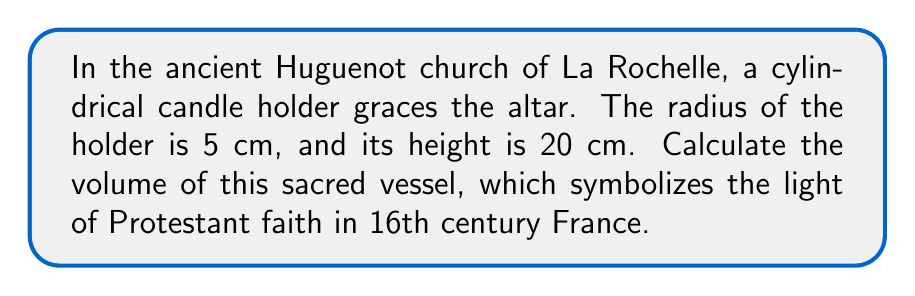Show me your answer to this math problem. To calculate the volume of a cylindrical candle holder, we use the formula for the volume of a cylinder:

$$V = \pi r^2 h$$

Where:
$V$ = volume
$r$ = radius of the base
$h$ = height of the cylinder

Given:
$r = 5$ cm
$h = 20$ cm

Let's substitute these values into the formula:

$$V = \pi (5\text{ cm})^2 (20\text{ cm})$$

Simplify:
$$V = \pi (25\text{ cm}^2) (20\text{ cm})$$
$$V = 500\pi\text{ cm}^3$$

We can leave the answer in terms of $\pi$ or calculate an approximate value:

$$V \approx 500 \times 3.14159 \approx 1570.80\text{ cm}^3$$

[asy]
import geometry;

size(100);
path p = circle((0,0),1);
path q = circle((0,2),1);
draw(p);
draw(q);
draw((-1,0)--(1,0));
draw((-1,2)--(1,2));
draw((-1,0)--(-1,2));
draw((1,0)--(1,2));
label("r", (0.5,0), S);
label("h", (1,1), E);
[/asy]
Answer: $500\pi\text{ cm}^3$ or approximately $1570.80\text{ cm}^3$ 